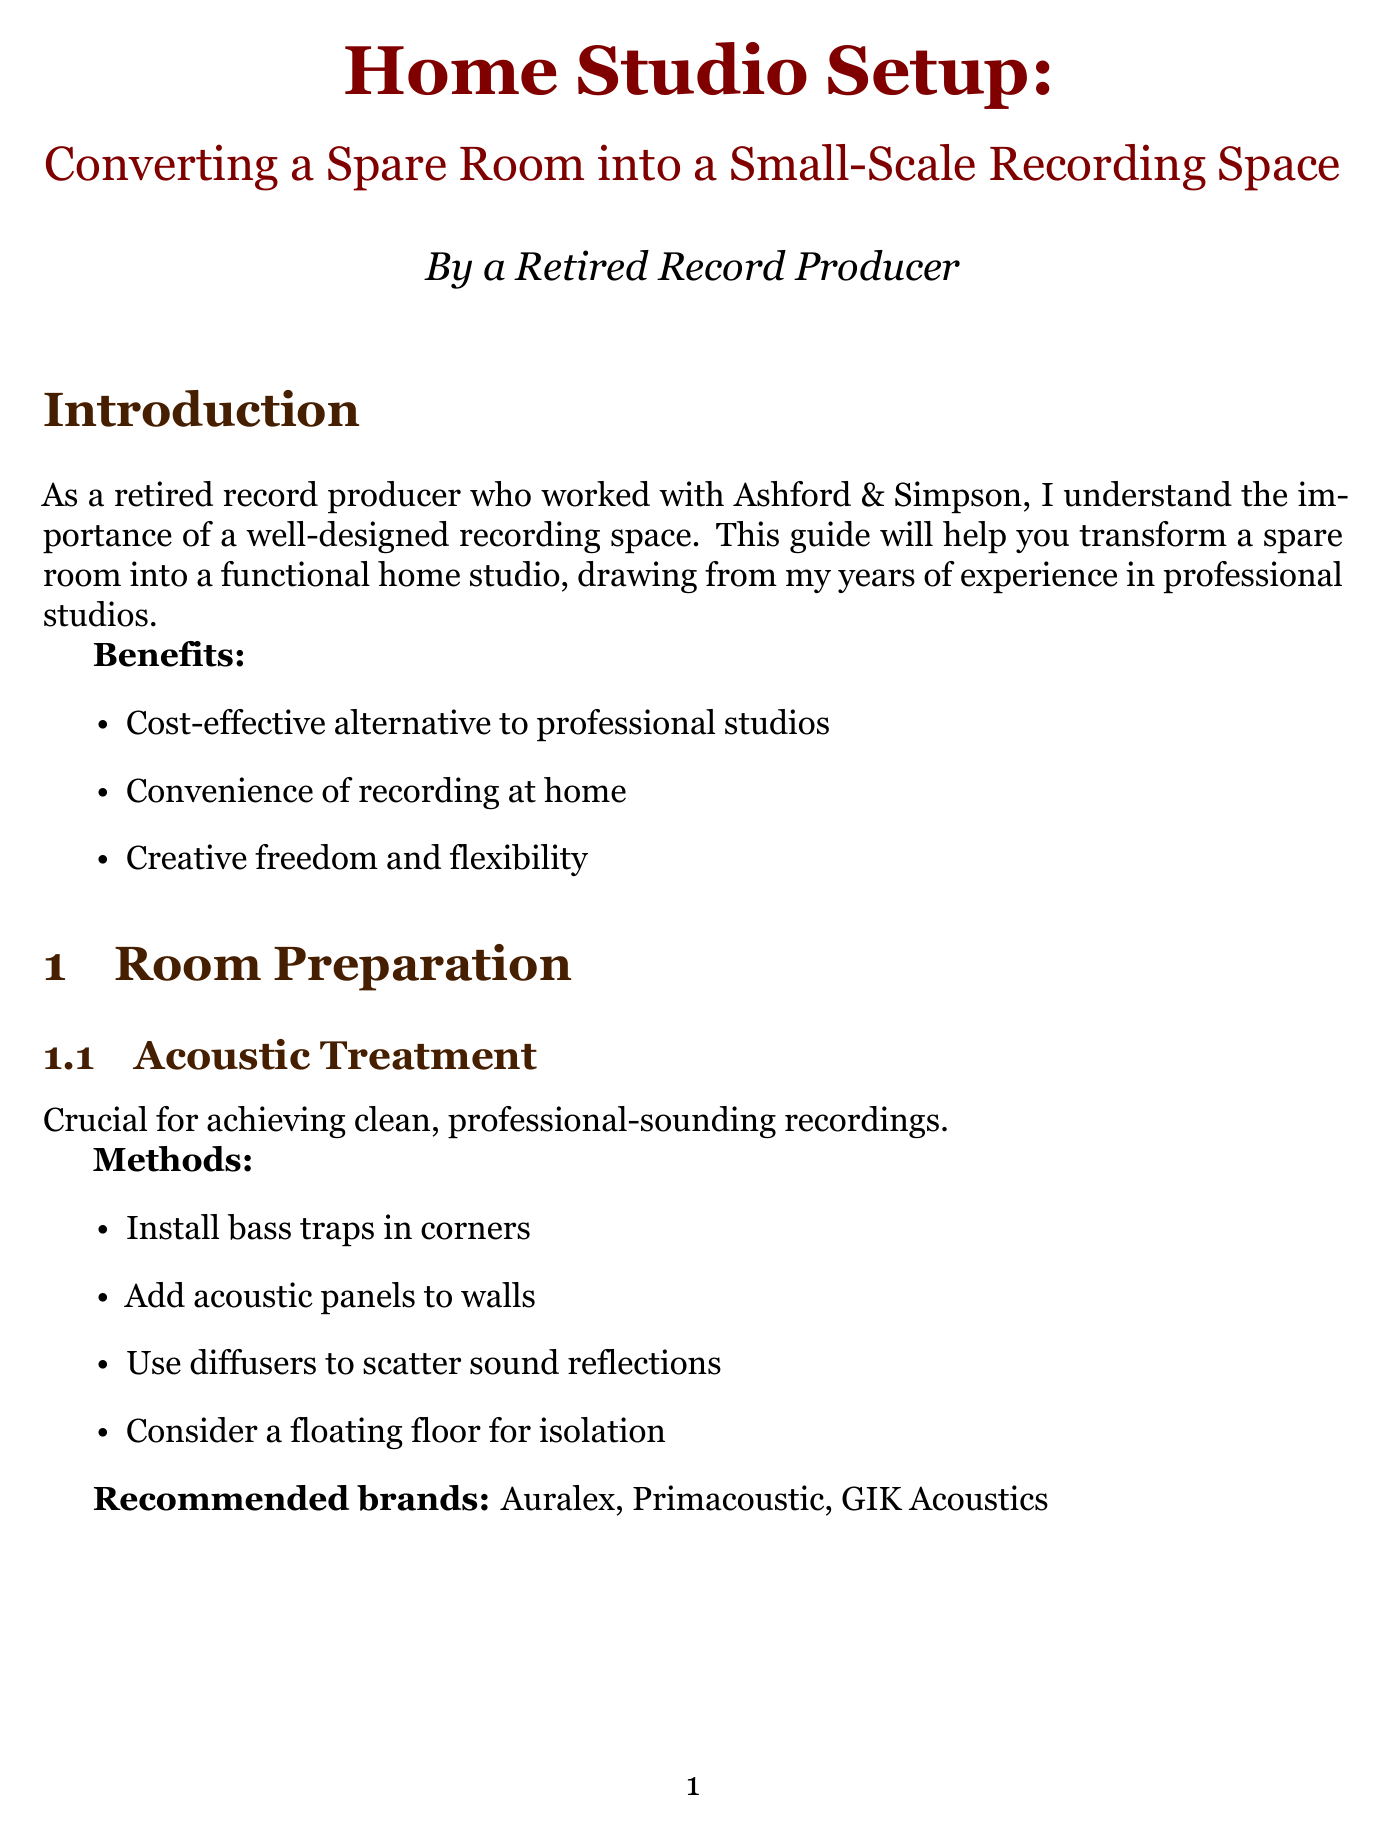what are the benefits of a home studio? The benefits include cost-effective alternative to professional studios, convenience of recording at home, and creative freedom and flexibility.
Answer: cost-effective alternative to professional studios, convenience of recording at home, creative freedom and flexibility what is the recommended RAM for a computer? The recommended RAM for a computer is mentioned explicitly in the document as 16GB minimum, 32GB preferred.
Answer: 16GB minimum, 32GB preferred which audio interface model is recommended? The document lists specific recommended models for audio interfaces, including Universal Audio Apollo Twin X.
Answer: Universal Audio Apollo Twin X what type of microphones are suggested for a home studio? The document outlines types of microphones, which include large-diaphragm condenser, dynamic, and ribbon.
Answer: large-diaphragm condenser, dynamic, ribbon how should the desk and monitors be positioned? The optimal positioning of the desk and monitors is described as needing to create an optimal listening triangle.
Answer: optimal listening triangle what is an essential type of plugin mentioned? Essential types of plugins for sound production listed in the document includes EQ, compression, reverb, and virtual instruments.
Answer: EQ what is a maintenance task for a home studio? The document specifies regular tasks, such as dusting equipment regularly.
Answer: dust equipment regularly what should be sealed to enhance soundproofing? One of the soundproofing techniques mentioned is to seal gaps around doors and windows.
Answer: gaps around doors and windows what is the advice for home studio layout? Considerations for studio layout include leaving space for instrument recording.
Answer: leave space for instrument recording 